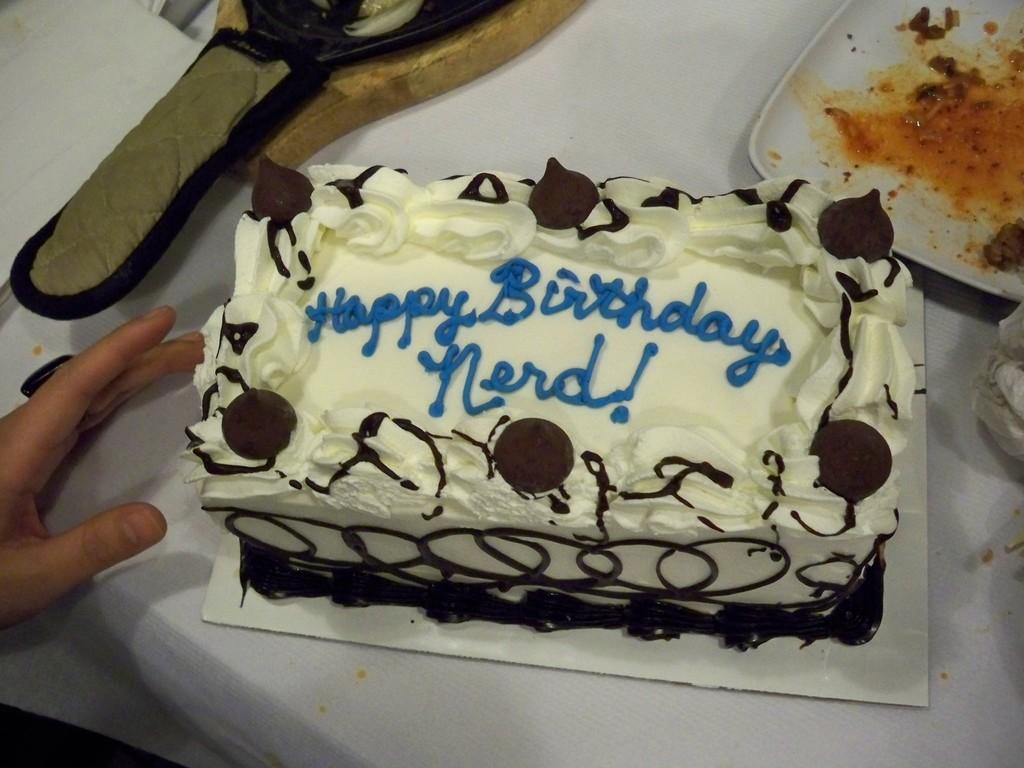What is on the table in the image? There is a person's hand, a cake, and a plate on the table. What might the person's hand be doing in the image? The person's hand might be touching or pointing at the cake or plate on the table. What is the primary object on the table? The primary object on the table is the cake. Can you see an airplane flying over the cake in the image? No, there is no airplane visible in the image. Is there a spy hiding behind the plate in the image? No, there is no spy or any hidden figure in the image. 